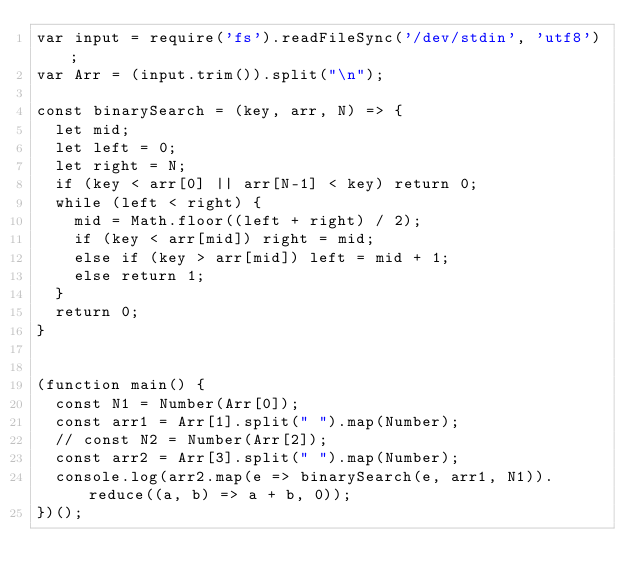Convert code to text. <code><loc_0><loc_0><loc_500><loc_500><_JavaScript_>var input = require('fs').readFileSync('/dev/stdin', 'utf8');
var Arr = (input.trim()).split("\n");

const binarySearch = (key, arr, N) => {
  let mid;
  let left = 0;
  let right = N;
  if (key < arr[0] || arr[N-1] < key) return 0;
  while (left < right) {
    mid = Math.floor((left + right) / 2);
    if (key < arr[mid]) right = mid;
    else if (key > arr[mid]) left = mid + 1;
    else return 1;
  }
  return 0;
}


(function main() {
  const N1 = Number(Arr[0]);
  const arr1 = Arr[1].split(" ").map(Number);
  // const N2 = Number(Arr[2]);
  const arr2 = Arr[3].split(" ").map(Number);
  console.log(arr2.map(e => binarySearch(e, arr1, N1)).reduce((a, b) => a + b, 0));
})();

</code> 